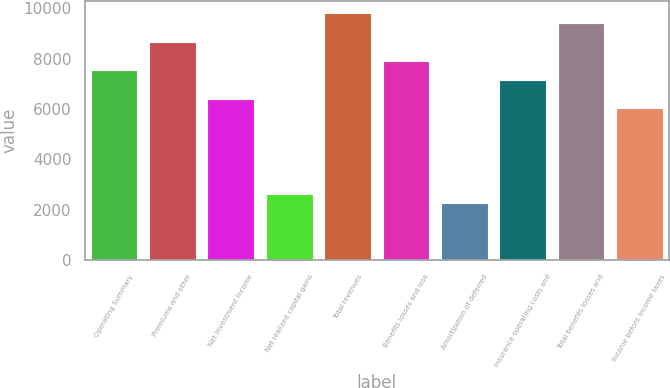<chart> <loc_0><loc_0><loc_500><loc_500><bar_chart><fcel>Operating Summary<fcel>Premiums and other<fcel>Net investment income<fcel>Net realized capital gains<fcel>Total revenues<fcel>Benefits losses and loss<fcel>Amortization of deferred<fcel>Insurance operating costs and<fcel>Total benefits losses and<fcel>Income before income taxes<nl><fcel>7539.2<fcel>8669.96<fcel>6408.44<fcel>2639.24<fcel>9800.72<fcel>7916.12<fcel>2262.32<fcel>7162.28<fcel>9423.8<fcel>6031.52<nl></chart> 